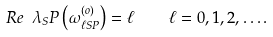<formula> <loc_0><loc_0><loc_500><loc_500>R e \ \lambda _ { S } P \left ( \omega ^ { ( o ) } _ { \ell S P } \right ) = \ell \quad \ell = 0 , 1 , 2 , \dots .</formula> 